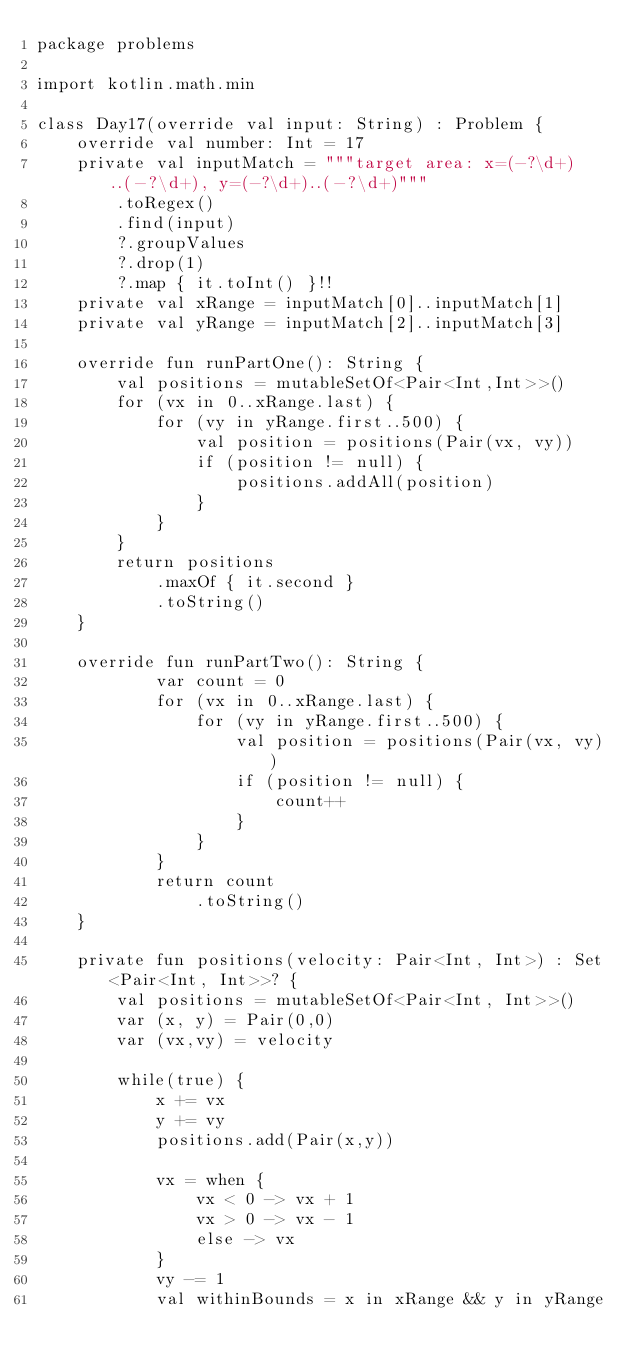<code> <loc_0><loc_0><loc_500><loc_500><_Kotlin_>package problems

import kotlin.math.min

class Day17(override val input: String) : Problem {
    override val number: Int = 17
    private val inputMatch = """target area: x=(-?\d+)..(-?\d+), y=(-?\d+)..(-?\d+)"""
        .toRegex()
        .find(input)
        ?.groupValues
        ?.drop(1)
        ?.map { it.toInt() }!!
    private val xRange = inputMatch[0]..inputMatch[1]
    private val yRange = inputMatch[2]..inputMatch[3]

    override fun runPartOne(): String {
        val positions = mutableSetOf<Pair<Int,Int>>()
        for (vx in 0..xRange.last) {
            for (vy in yRange.first..500) {
                val position = positions(Pair(vx, vy))
                if (position != null) {
                    positions.addAll(position)
                }
            }
        }
        return positions
            .maxOf { it.second }
            .toString()
    }

    override fun runPartTwo(): String {
            var count = 0
            for (vx in 0..xRange.last) {
                for (vy in yRange.first..500) {
                    val position = positions(Pair(vx, vy))
                    if (position != null) {
                        count++
                    }
                }
            }
            return count
                .toString()
    }

    private fun positions(velocity: Pair<Int, Int>) : Set<Pair<Int, Int>>? {
        val positions = mutableSetOf<Pair<Int, Int>>()
        var (x, y) = Pair(0,0)
        var (vx,vy) = velocity

        while(true) {
            x += vx
            y += vy
            positions.add(Pair(x,y))

            vx = when {
                vx < 0 -> vx + 1
                vx > 0 -> vx - 1
                else -> vx
            }
            vy -= 1
            val withinBounds = x in xRange && y in yRange</code> 